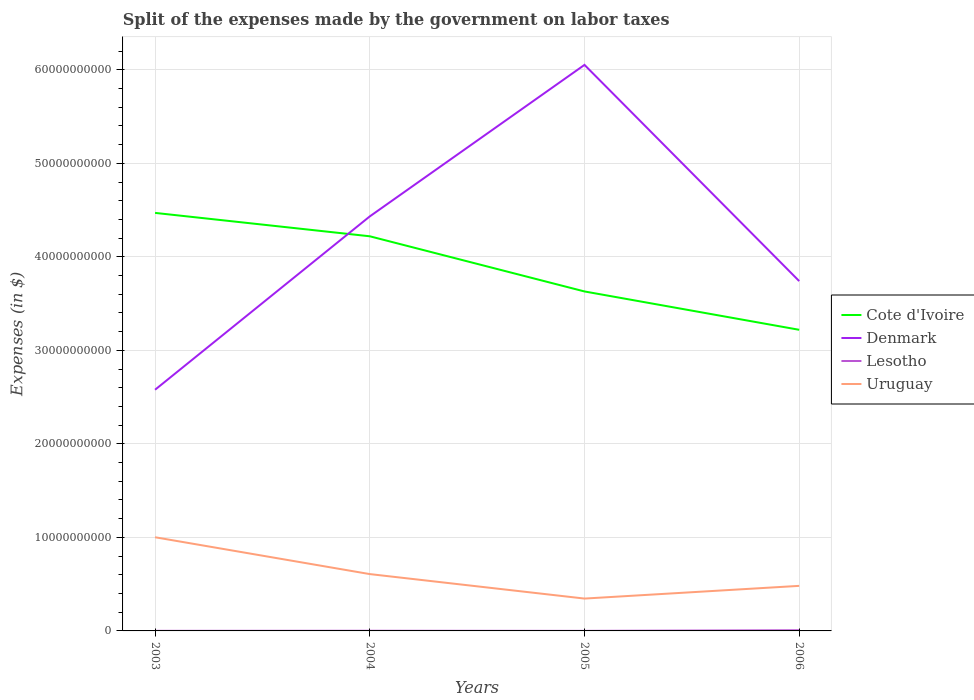Is the number of lines equal to the number of legend labels?
Provide a succinct answer. Yes. Across all years, what is the maximum expenses made by the government on labor taxes in Uruguay?
Ensure brevity in your answer.  3.46e+09. What is the total expenses made by the government on labor taxes in Denmark in the graph?
Your answer should be very brief. -1.85e+1. What is the difference between the highest and the second highest expenses made by the government on labor taxes in Denmark?
Your response must be concise. 3.47e+1. How many lines are there?
Give a very brief answer. 4. How many years are there in the graph?
Give a very brief answer. 4. Does the graph contain any zero values?
Your answer should be compact. No. Does the graph contain grids?
Your answer should be compact. Yes. What is the title of the graph?
Give a very brief answer. Split of the expenses made by the government on labor taxes. Does "Curacao" appear as one of the legend labels in the graph?
Give a very brief answer. No. What is the label or title of the X-axis?
Provide a short and direct response. Years. What is the label or title of the Y-axis?
Provide a short and direct response. Expenses (in $). What is the Expenses (in $) in Cote d'Ivoire in 2003?
Your response must be concise. 4.47e+1. What is the Expenses (in $) in Denmark in 2003?
Offer a terse response. 2.58e+1. What is the Expenses (in $) in Lesotho in 2003?
Give a very brief answer. 1.05e+07. What is the Expenses (in $) of Uruguay in 2003?
Make the answer very short. 1.00e+1. What is the Expenses (in $) in Cote d'Ivoire in 2004?
Your response must be concise. 4.22e+1. What is the Expenses (in $) in Denmark in 2004?
Your answer should be compact. 4.43e+1. What is the Expenses (in $) in Lesotho in 2004?
Your response must be concise. 1.78e+07. What is the Expenses (in $) in Uruguay in 2004?
Offer a very short reply. 6.08e+09. What is the Expenses (in $) of Cote d'Ivoire in 2005?
Your answer should be very brief. 3.63e+1. What is the Expenses (in $) in Denmark in 2005?
Your answer should be compact. 6.05e+1. What is the Expenses (in $) in Lesotho in 2005?
Offer a terse response. 6.74e+06. What is the Expenses (in $) in Uruguay in 2005?
Offer a very short reply. 3.46e+09. What is the Expenses (in $) in Cote d'Ivoire in 2006?
Your answer should be compact. 3.22e+1. What is the Expenses (in $) in Denmark in 2006?
Ensure brevity in your answer.  3.74e+1. What is the Expenses (in $) of Lesotho in 2006?
Give a very brief answer. 7.48e+07. What is the Expenses (in $) in Uruguay in 2006?
Keep it short and to the point. 4.82e+09. Across all years, what is the maximum Expenses (in $) of Cote d'Ivoire?
Keep it short and to the point. 4.47e+1. Across all years, what is the maximum Expenses (in $) of Denmark?
Provide a succinct answer. 6.05e+1. Across all years, what is the maximum Expenses (in $) of Lesotho?
Give a very brief answer. 7.48e+07. Across all years, what is the maximum Expenses (in $) in Uruguay?
Provide a succinct answer. 1.00e+1. Across all years, what is the minimum Expenses (in $) in Cote d'Ivoire?
Make the answer very short. 3.22e+1. Across all years, what is the minimum Expenses (in $) of Denmark?
Provide a succinct answer. 2.58e+1. Across all years, what is the minimum Expenses (in $) in Lesotho?
Your answer should be very brief. 6.74e+06. Across all years, what is the minimum Expenses (in $) in Uruguay?
Your answer should be very brief. 3.46e+09. What is the total Expenses (in $) in Cote d'Ivoire in the graph?
Your answer should be very brief. 1.55e+11. What is the total Expenses (in $) in Denmark in the graph?
Your answer should be compact. 1.68e+11. What is the total Expenses (in $) in Lesotho in the graph?
Make the answer very short. 1.10e+08. What is the total Expenses (in $) in Uruguay in the graph?
Offer a very short reply. 2.44e+1. What is the difference between the Expenses (in $) of Cote d'Ivoire in 2003 and that in 2004?
Make the answer very short. 2.50e+09. What is the difference between the Expenses (in $) of Denmark in 2003 and that in 2004?
Provide a short and direct response. -1.85e+1. What is the difference between the Expenses (in $) in Lesotho in 2003 and that in 2004?
Make the answer very short. -7.32e+06. What is the difference between the Expenses (in $) of Uruguay in 2003 and that in 2004?
Offer a terse response. 3.94e+09. What is the difference between the Expenses (in $) of Cote d'Ivoire in 2003 and that in 2005?
Your response must be concise. 8.40e+09. What is the difference between the Expenses (in $) of Denmark in 2003 and that in 2005?
Provide a short and direct response. -3.47e+1. What is the difference between the Expenses (in $) in Lesotho in 2003 and that in 2005?
Ensure brevity in your answer.  3.74e+06. What is the difference between the Expenses (in $) of Uruguay in 2003 and that in 2005?
Offer a very short reply. 6.56e+09. What is the difference between the Expenses (in $) in Cote d'Ivoire in 2003 and that in 2006?
Offer a terse response. 1.25e+1. What is the difference between the Expenses (in $) of Denmark in 2003 and that in 2006?
Provide a short and direct response. -1.16e+1. What is the difference between the Expenses (in $) of Lesotho in 2003 and that in 2006?
Provide a short and direct response. -6.43e+07. What is the difference between the Expenses (in $) in Uruguay in 2003 and that in 2006?
Your response must be concise. 5.20e+09. What is the difference between the Expenses (in $) of Cote d'Ivoire in 2004 and that in 2005?
Provide a succinct answer. 5.90e+09. What is the difference between the Expenses (in $) of Denmark in 2004 and that in 2005?
Offer a very short reply. -1.62e+1. What is the difference between the Expenses (in $) in Lesotho in 2004 and that in 2005?
Keep it short and to the point. 1.11e+07. What is the difference between the Expenses (in $) of Uruguay in 2004 and that in 2005?
Provide a succinct answer. 2.62e+09. What is the difference between the Expenses (in $) in Cote d'Ivoire in 2004 and that in 2006?
Provide a succinct answer. 1.00e+1. What is the difference between the Expenses (in $) of Denmark in 2004 and that in 2006?
Make the answer very short. 6.92e+09. What is the difference between the Expenses (in $) of Lesotho in 2004 and that in 2006?
Offer a terse response. -5.70e+07. What is the difference between the Expenses (in $) of Uruguay in 2004 and that in 2006?
Provide a short and direct response. 1.26e+09. What is the difference between the Expenses (in $) in Cote d'Ivoire in 2005 and that in 2006?
Give a very brief answer. 4.10e+09. What is the difference between the Expenses (in $) of Denmark in 2005 and that in 2006?
Provide a short and direct response. 2.31e+1. What is the difference between the Expenses (in $) in Lesotho in 2005 and that in 2006?
Give a very brief answer. -6.81e+07. What is the difference between the Expenses (in $) in Uruguay in 2005 and that in 2006?
Make the answer very short. -1.36e+09. What is the difference between the Expenses (in $) in Cote d'Ivoire in 2003 and the Expenses (in $) in Denmark in 2004?
Offer a very short reply. 3.74e+08. What is the difference between the Expenses (in $) of Cote d'Ivoire in 2003 and the Expenses (in $) of Lesotho in 2004?
Provide a succinct answer. 4.47e+1. What is the difference between the Expenses (in $) of Cote d'Ivoire in 2003 and the Expenses (in $) of Uruguay in 2004?
Your answer should be very brief. 3.86e+1. What is the difference between the Expenses (in $) in Denmark in 2003 and the Expenses (in $) in Lesotho in 2004?
Offer a terse response. 2.58e+1. What is the difference between the Expenses (in $) in Denmark in 2003 and the Expenses (in $) in Uruguay in 2004?
Keep it short and to the point. 1.97e+1. What is the difference between the Expenses (in $) of Lesotho in 2003 and the Expenses (in $) of Uruguay in 2004?
Make the answer very short. -6.07e+09. What is the difference between the Expenses (in $) in Cote d'Ivoire in 2003 and the Expenses (in $) in Denmark in 2005?
Your answer should be compact. -1.58e+1. What is the difference between the Expenses (in $) in Cote d'Ivoire in 2003 and the Expenses (in $) in Lesotho in 2005?
Your answer should be very brief. 4.47e+1. What is the difference between the Expenses (in $) in Cote d'Ivoire in 2003 and the Expenses (in $) in Uruguay in 2005?
Your answer should be very brief. 4.12e+1. What is the difference between the Expenses (in $) of Denmark in 2003 and the Expenses (in $) of Lesotho in 2005?
Your answer should be very brief. 2.58e+1. What is the difference between the Expenses (in $) in Denmark in 2003 and the Expenses (in $) in Uruguay in 2005?
Offer a very short reply. 2.23e+1. What is the difference between the Expenses (in $) in Lesotho in 2003 and the Expenses (in $) in Uruguay in 2005?
Your response must be concise. -3.45e+09. What is the difference between the Expenses (in $) of Cote d'Ivoire in 2003 and the Expenses (in $) of Denmark in 2006?
Provide a short and direct response. 7.29e+09. What is the difference between the Expenses (in $) of Cote d'Ivoire in 2003 and the Expenses (in $) of Lesotho in 2006?
Make the answer very short. 4.46e+1. What is the difference between the Expenses (in $) in Cote d'Ivoire in 2003 and the Expenses (in $) in Uruguay in 2006?
Offer a very short reply. 3.99e+1. What is the difference between the Expenses (in $) of Denmark in 2003 and the Expenses (in $) of Lesotho in 2006?
Your answer should be very brief. 2.57e+1. What is the difference between the Expenses (in $) in Denmark in 2003 and the Expenses (in $) in Uruguay in 2006?
Offer a terse response. 2.10e+1. What is the difference between the Expenses (in $) of Lesotho in 2003 and the Expenses (in $) of Uruguay in 2006?
Ensure brevity in your answer.  -4.81e+09. What is the difference between the Expenses (in $) in Cote d'Ivoire in 2004 and the Expenses (in $) in Denmark in 2005?
Your answer should be compact. -1.83e+1. What is the difference between the Expenses (in $) of Cote d'Ivoire in 2004 and the Expenses (in $) of Lesotho in 2005?
Provide a short and direct response. 4.22e+1. What is the difference between the Expenses (in $) in Cote d'Ivoire in 2004 and the Expenses (in $) in Uruguay in 2005?
Provide a short and direct response. 3.87e+1. What is the difference between the Expenses (in $) of Denmark in 2004 and the Expenses (in $) of Lesotho in 2005?
Give a very brief answer. 4.43e+1. What is the difference between the Expenses (in $) of Denmark in 2004 and the Expenses (in $) of Uruguay in 2005?
Your answer should be very brief. 4.09e+1. What is the difference between the Expenses (in $) of Lesotho in 2004 and the Expenses (in $) of Uruguay in 2005?
Provide a succinct answer. -3.44e+09. What is the difference between the Expenses (in $) in Cote d'Ivoire in 2004 and the Expenses (in $) in Denmark in 2006?
Give a very brief answer. 4.79e+09. What is the difference between the Expenses (in $) in Cote d'Ivoire in 2004 and the Expenses (in $) in Lesotho in 2006?
Offer a terse response. 4.21e+1. What is the difference between the Expenses (in $) of Cote d'Ivoire in 2004 and the Expenses (in $) of Uruguay in 2006?
Give a very brief answer. 3.74e+1. What is the difference between the Expenses (in $) in Denmark in 2004 and the Expenses (in $) in Lesotho in 2006?
Your answer should be compact. 4.43e+1. What is the difference between the Expenses (in $) of Denmark in 2004 and the Expenses (in $) of Uruguay in 2006?
Your answer should be very brief. 3.95e+1. What is the difference between the Expenses (in $) of Lesotho in 2004 and the Expenses (in $) of Uruguay in 2006?
Your answer should be compact. -4.80e+09. What is the difference between the Expenses (in $) in Cote d'Ivoire in 2005 and the Expenses (in $) in Denmark in 2006?
Offer a very short reply. -1.11e+09. What is the difference between the Expenses (in $) in Cote d'Ivoire in 2005 and the Expenses (in $) in Lesotho in 2006?
Your response must be concise. 3.62e+1. What is the difference between the Expenses (in $) of Cote d'Ivoire in 2005 and the Expenses (in $) of Uruguay in 2006?
Keep it short and to the point. 3.15e+1. What is the difference between the Expenses (in $) of Denmark in 2005 and the Expenses (in $) of Lesotho in 2006?
Keep it short and to the point. 6.05e+1. What is the difference between the Expenses (in $) in Denmark in 2005 and the Expenses (in $) in Uruguay in 2006?
Keep it short and to the point. 5.57e+1. What is the difference between the Expenses (in $) in Lesotho in 2005 and the Expenses (in $) in Uruguay in 2006?
Your answer should be very brief. -4.81e+09. What is the average Expenses (in $) in Cote d'Ivoire per year?
Ensure brevity in your answer.  3.88e+1. What is the average Expenses (in $) of Denmark per year?
Provide a short and direct response. 4.20e+1. What is the average Expenses (in $) in Lesotho per year?
Provide a succinct answer. 2.75e+07. What is the average Expenses (in $) of Uruguay per year?
Provide a short and direct response. 6.09e+09. In the year 2003, what is the difference between the Expenses (in $) of Cote d'Ivoire and Expenses (in $) of Denmark?
Give a very brief answer. 1.89e+1. In the year 2003, what is the difference between the Expenses (in $) of Cote d'Ivoire and Expenses (in $) of Lesotho?
Ensure brevity in your answer.  4.47e+1. In the year 2003, what is the difference between the Expenses (in $) in Cote d'Ivoire and Expenses (in $) in Uruguay?
Offer a very short reply. 3.47e+1. In the year 2003, what is the difference between the Expenses (in $) of Denmark and Expenses (in $) of Lesotho?
Offer a terse response. 2.58e+1. In the year 2003, what is the difference between the Expenses (in $) of Denmark and Expenses (in $) of Uruguay?
Provide a short and direct response. 1.58e+1. In the year 2003, what is the difference between the Expenses (in $) of Lesotho and Expenses (in $) of Uruguay?
Offer a terse response. -1.00e+1. In the year 2004, what is the difference between the Expenses (in $) in Cote d'Ivoire and Expenses (in $) in Denmark?
Provide a succinct answer. -2.13e+09. In the year 2004, what is the difference between the Expenses (in $) in Cote d'Ivoire and Expenses (in $) in Lesotho?
Offer a terse response. 4.22e+1. In the year 2004, what is the difference between the Expenses (in $) of Cote d'Ivoire and Expenses (in $) of Uruguay?
Your answer should be very brief. 3.61e+1. In the year 2004, what is the difference between the Expenses (in $) in Denmark and Expenses (in $) in Lesotho?
Your answer should be very brief. 4.43e+1. In the year 2004, what is the difference between the Expenses (in $) of Denmark and Expenses (in $) of Uruguay?
Your answer should be compact. 3.82e+1. In the year 2004, what is the difference between the Expenses (in $) of Lesotho and Expenses (in $) of Uruguay?
Provide a short and direct response. -6.06e+09. In the year 2005, what is the difference between the Expenses (in $) in Cote d'Ivoire and Expenses (in $) in Denmark?
Make the answer very short. -2.42e+1. In the year 2005, what is the difference between the Expenses (in $) of Cote d'Ivoire and Expenses (in $) of Lesotho?
Provide a succinct answer. 3.63e+1. In the year 2005, what is the difference between the Expenses (in $) in Cote d'Ivoire and Expenses (in $) in Uruguay?
Your response must be concise. 3.28e+1. In the year 2005, what is the difference between the Expenses (in $) of Denmark and Expenses (in $) of Lesotho?
Provide a short and direct response. 6.05e+1. In the year 2005, what is the difference between the Expenses (in $) in Denmark and Expenses (in $) in Uruguay?
Provide a short and direct response. 5.71e+1. In the year 2005, what is the difference between the Expenses (in $) of Lesotho and Expenses (in $) of Uruguay?
Your answer should be compact. -3.45e+09. In the year 2006, what is the difference between the Expenses (in $) in Cote d'Ivoire and Expenses (in $) in Denmark?
Provide a short and direct response. -5.21e+09. In the year 2006, what is the difference between the Expenses (in $) in Cote d'Ivoire and Expenses (in $) in Lesotho?
Give a very brief answer. 3.21e+1. In the year 2006, what is the difference between the Expenses (in $) of Cote d'Ivoire and Expenses (in $) of Uruguay?
Your response must be concise. 2.74e+1. In the year 2006, what is the difference between the Expenses (in $) in Denmark and Expenses (in $) in Lesotho?
Make the answer very short. 3.73e+1. In the year 2006, what is the difference between the Expenses (in $) in Denmark and Expenses (in $) in Uruguay?
Give a very brief answer. 3.26e+1. In the year 2006, what is the difference between the Expenses (in $) of Lesotho and Expenses (in $) of Uruguay?
Keep it short and to the point. -4.74e+09. What is the ratio of the Expenses (in $) of Cote d'Ivoire in 2003 to that in 2004?
Keep it short and to the point. 1.06. What is the ratio of the Expenses (in $) in Denmark in 2003 to that in 2004?
Your response must be concise. 0.58. What is the ratio of the Expenses (in $) in Lesotho in 2003 to that in 2004?
Your answer should be compact. 0.59. What is the ratio of the Expenses (in $) of Uruguay in 2003 to that in 2004?
Ensure brevity in your answer.  1.65. What is the ratio of the Expenses (in $) in Cote d'Ivoire in 2003 to that in 2005?
Ensure brevity in your answer.  1.23. What is the ratio of the Expenses (in $) of Denmark in 2003 to that in 2005?
Ensure brevity in your answer.  0.43. What is the ratio of the Expenses (in $) of Lesotho in 2003 to that in 2005?
Provide a short and direct response. 1.56. What is the ratio of the Expenses (in $) of Uruguay in 2003 to that in 2005?
Ensure brevity in your answer.  2.9. What is the ratio of the Expenses (in $) of Cote d'Ivoire in 2003 to that in 2006?
Your answer should be compact. 1.39. What is the ratio of the Expenses (in $) in Denmark in 2003 to that in 2006?
Give a very brief answer. 0.69. What is the ratio of the Expenses (in $) in Lesotho in 2003 to that in 2006?
Offer a very short reply. 0.14. What is the ratio of the Expenses (in $) in Uruguay in 2003 to that in 2006?
Offer a very short reply. 2.08. What is the ratio of the Expenses (in $) in Cote d'Ivoire in 2004 to that in 2005?
Provide a succinct answer. 1.16. What is the ratio of the Expenses (in $) in Denmark in 2004 to that in 2005?
Your answer should be compact. 0.73. What is the ratio of the Expenses (in $) of Lesotho in 2004 to that in 2005?
Provide a short and direct response. 2.64. What is the ratio of the Expenses (in $) in Uruguay in 2004 to that in 2005?
Make the answer very short. 1.76. What is the ratio of the Expenses (in $) in Cote d'Ivoire in 2004 to that in 2006?
Offer a terse response. 1.31. What is the ratio of the Expenses (in $) in Denmark in 2004 to that in 2006?
Offer a terse response. 1.18. What is the ratio of the Expenses (in $) of Lesotho in 2004 to that in 2006?
Ensure brevity in your answer.  0.24. What is the ratio of the Expenses (in $) of Uruguay in 2004 to that in 2006?
Your answer should be very brief. 1.26. What is the ratio of the Expenses (in $) in Cote d'Ivoire in 2005 to that in 2006?
Keep it short and to the point. 1.13. What is the ratio of the Expenses (in $) in Denmark in 2005 to that in 2006?
Your answer should be compact. 1.62. What is the ratio of the Expenses (in $) of Lesotho in 2005 to that in 2006?
Make the answer very short. 0.09. What is the ratio of the Expenses (in $) of Uruguay in 2005 to that in 2006?
Your answer should be very brief. 0.72. What is the difference between the highest and the second highest Expenses (in $) of Cote d'Ivoire?
Ensure brevity in your answer.  2.50e+09. What is the difference between the highest and the second highest Expenses (in $) in Denmark?
Your response must be concise. 1.62e+1. What is the difference between the highest and the second highest Expenses (in $) of Lesotho?
Ensure brevity in your answer.  5.70e+07. What is the difference between the highest and the second highest Expenses (in $) in Uruguay?
Your answer should be compact. 3.94e+09. What is the difference between the highest and the lowest Expenses (in $) in Cote d'Ivoire?
Give a very brief answer. 1.25e+1. What is the difference between the highest and the lowest Expenses (in $) of Denmark?
Provide a succinct answer. 3.47e+1. What is the difference between the highest and the lowest Expenses (in $) in Lesotho?
Ensure brevity in your answer.  6.81e+07. What is the difference between the highest and the lowest Expenses (in $) of Uruguay?
Make the answer very short. 6.56e+09. 